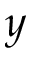Convert formula to latex. <formula><loc_0><loc_0><loc_500><loc_500>y</formula> 